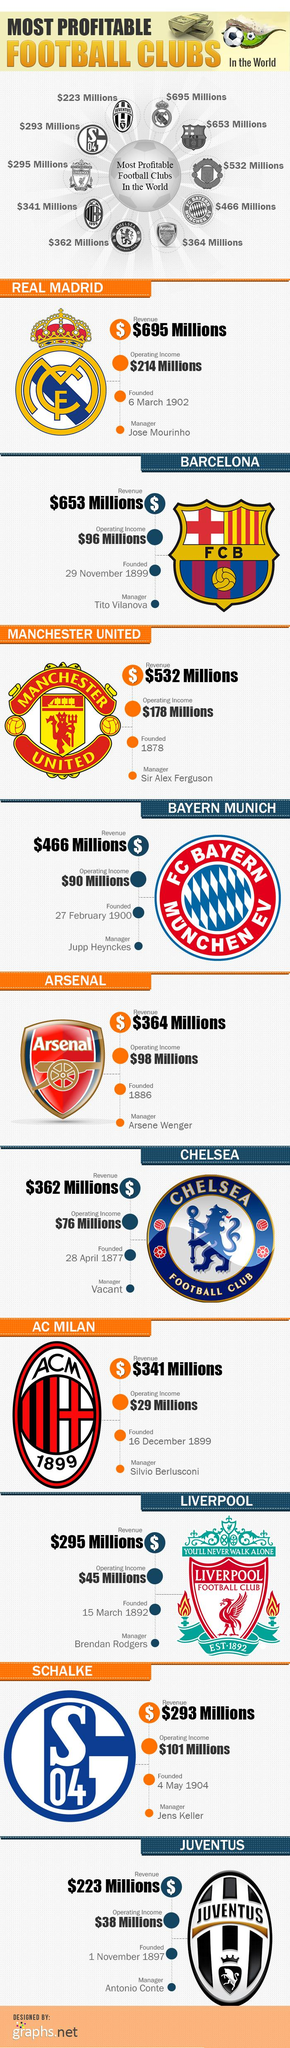Mention a couple of crucial points in this snapshot. The logo of Bayern Munich features a diamond shape that is not blue, and it is either red or white. AC Milan has the least operating income among all football clubs. The football club logo that features a cross sign in its crown is Real Madrid. The infographic displays four stacks of currency. The logo of a football club, excluding the logo of AC Milan, is in the shape of an oval. This club is Juventus. 